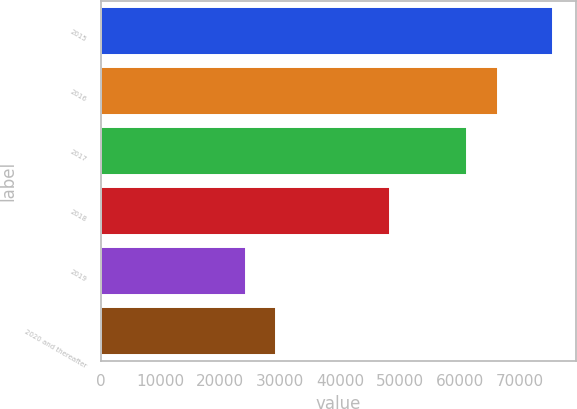Convert chart. <chart><loc_0><loc_0><loc_500><loc_500><bar_chart><fcel>2015<fcel>2016<fcel>2017<fcel>2018<fcel>2019<fcel>2020 and thereafter<nl><fcel>75629<fcel>66315<fcel>61138<fcel>48292<fcel>24211<fcel>29352.8<nl></chart> 